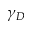Convert formula to latex. <formula><loc_0><loc_0><loc_500><loc_500>\gamma _ { D }</formula> 